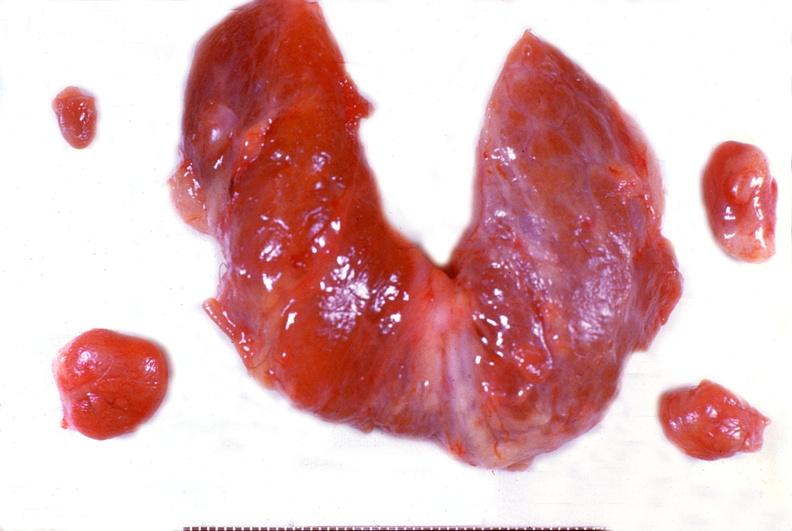what is present?
Answer the question using a single word or phrase. Endocrine 